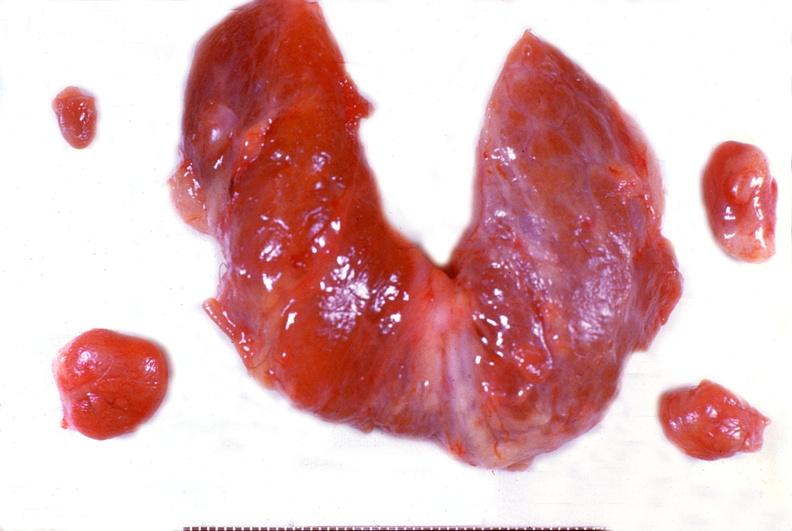what is present?
Answer the question using a single word or phrase. Endocrine 